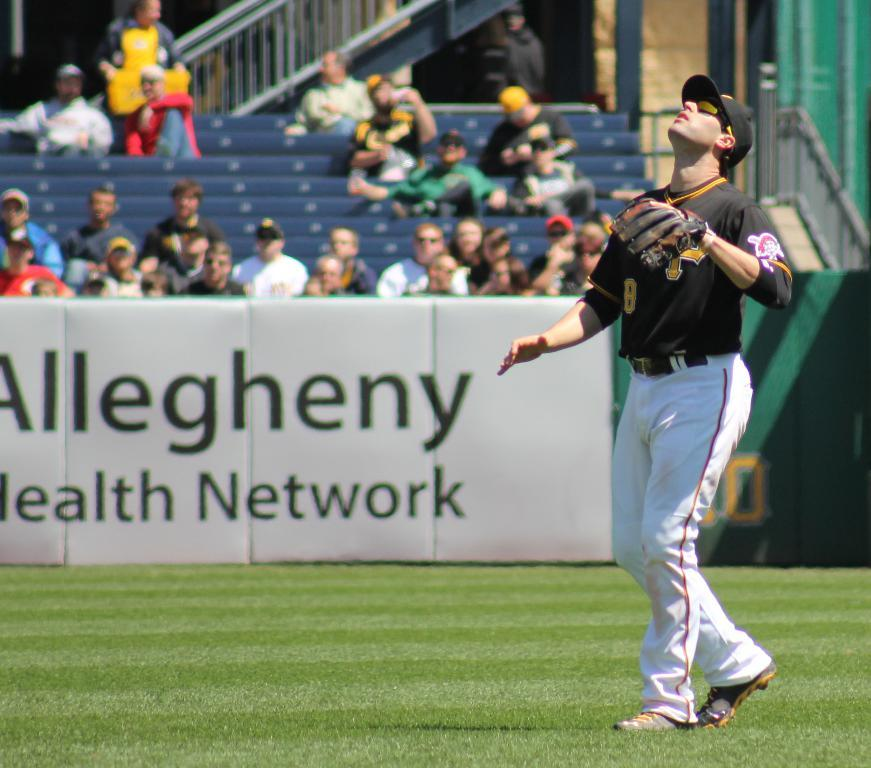<image>
Write a terse but informative summary of the picture. Fans watch from the stands behind an advertisement for Allegheny Health Network while a baseball player looks up in anticipation of catching a the ball. 